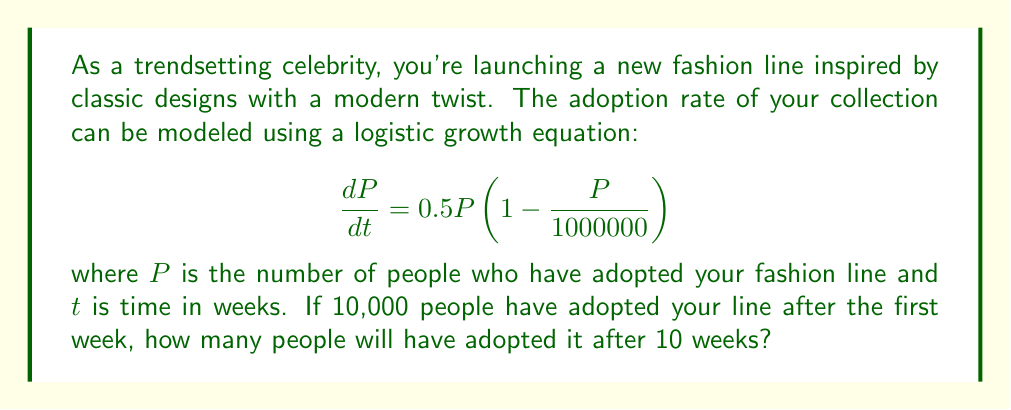Help me with this question. To solve this problem, we need to use the logistic growth equation and its solution. The general form of the logistic equation is:

$$\frac{dP}{dt} = rP(1 - \frac{P}{K})$$

where $r$ is the growth rate and $K$ is the carrying capacity. In this case, $r = 0.5$ and $K = 1,000,000$.

The solution to the logistic equation is:

$$P(t) = \frac{K}{1 + (\frac{K}{P_0} - 1)e^{-rt}}$$

where $P_0$ is the initial population.

Given information:
- $P_0 = 10,000$ (after the first week)
- $K = 1,000,000$
- $r = 0.5$
- $t = 10$ weeks (we want to find $P(10)$)

Plugging these values into the solution:

$$P(10) = \frac{1,000,000}{1 + (\frac{1,000,000}{10,000} - 1)e^{-0.5 \cdot 10}}$$

$$= \frac{1,000,000}{1 + 99e^{-5}}$$

$$\approx 148,259$$

Therefore, after 10 weeks, approximately 148,259 people will have adopted your fashion line.
Answer: $148,259$ people (rounded to the nearest whole number) 